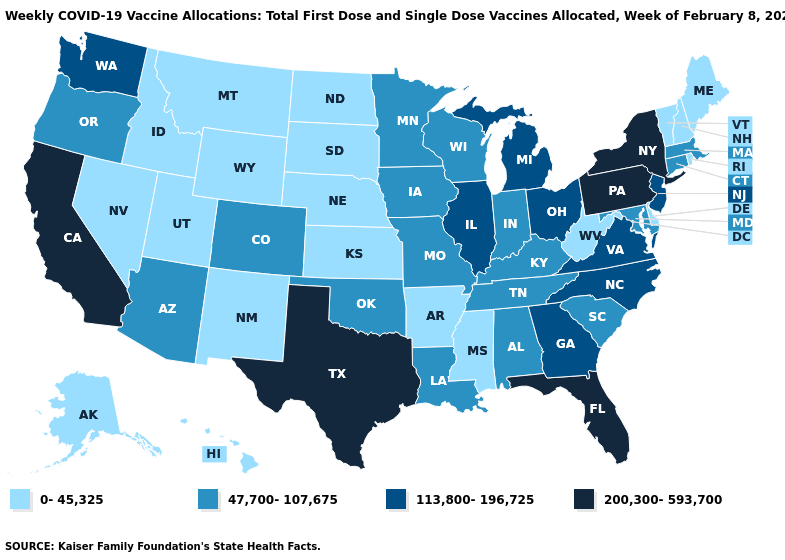What is the highest value in states that border North Dakota?
Quick response, please. 47,700-107,675. Which states have the lowest value in the USA?
Give a very brief answer. Alaska, Arkansas, Delaware, Hawaii, Idaho, Kansas, Maine, Mississippi, Montana, Nebraska, Nevada, New Hampshire, New Mexico, North Dakota, Rhode Island, South Dakota, Utah, Vermont, West Virginia, Wyoming. What is the value of North Carolina?
Short answer required. 113,800-196,725. Name the states that have a value in the range 47,700-107,675?
Keep it brief. Alabama, Arizona, Colorado, Connecticut, Indiana, Iowa, Kentucky, Louisiana, Maryland, Massachusetts, Minnesota, Missouri, Oklahoma, Oregon, South Carolina, Tennessee, Wisconsin. How many symbols are there in the legend?
Write a very short answer. 4. Does Kansas have the same value as Ohio?
Keep it brief. No. Which states have the highest value in the USA?
Be succinct. California, Florida, New York, Pennsylvania, Texas. What is the highest value in states that border Washington?
Answer briefly. 47,700-107,675. Does Nebraska have the lowest value in the MidWest?
Quick response, please. Yes. What is the lowest value in the USA?
Write a very short answer. 0-45,325. What is the value of Oregon?
Concise answer only. 47,700-107,675. Does Iowa have the lowest value in the MidWest?
Short answer required. No. What is the value of Kansas?
Write a very short answer. 0-45,325. What is the value of Iowa?
Give a very brief answer. 47,700-107,675. Does New Jersey have the lowest value in the Northeast?
Keep it brief. No. 